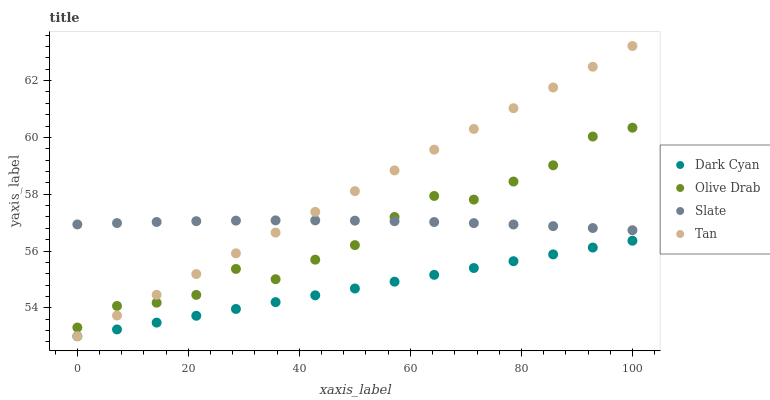Does Dark Cyan have the minimum area under the curve?
Answer yes or no. Yes. Does Tan have the maximum area under the curve?
Answer yes or no. Yes. Does Slate have the minimum area under the curve?
Answer yes or no. No. Does Slate have the maximum area under the curve?
Answer yes or no. No. Is Dark Cyan the smoothest?
Answer yes or no. Yes. Is Olive Drab the roughest?
Answer yes or no. Yes. Is Slate the smoothest?
Answer yes or no. No. Is Slate the roughest?
Answer yes or no. No. Does Dark Cyan have the lowest value?
Answer yes or no. Yes. Does Slate have the lowest value?
Answer yes or no. No. Does Tan have the highest value?
Answer yes or no. Yes. Does Slate have the highest value?
Answer yes or no. No. Is Dark Cyan less than Slate?
Answer yes or no. Yes. Is Slate greater than Dark Cyan?
Answer yes or no. Yes. Does Dark Cyan intersect Tan?
Answer yes or no. Yes. Is Dark Cyan less than Tan?
Answer yes or no. No. Is Dark Cyan greater than Tan?
Answer yes or no. No. Does Dark Cyan intersect Slate?
Answer yes or no. No. 